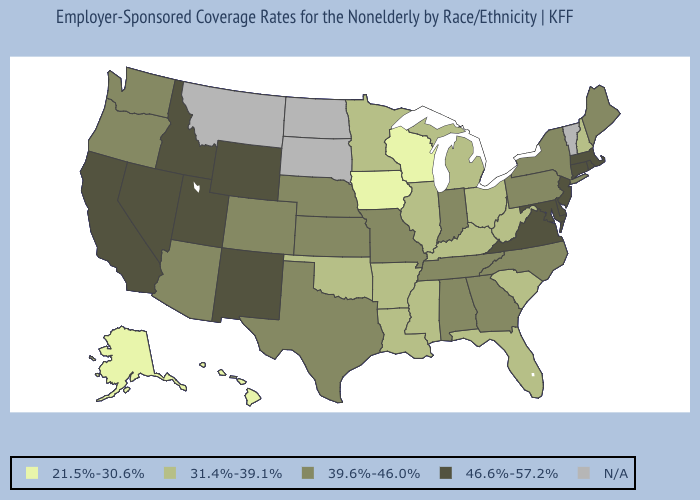Which states have the lowest value in the USA?
Quick response, please. Alaska, Hawaii, Iowa, Wisconsin. Among the states that border New Mexico , does Texas have the lowest value?
Quick response, please. No. How many symbols are there in the legend?
Short answer required. 5. What is the value of North Carolina?
Short answer required. 39.6%-46.0%. Does Iowa have the lowest value in the USA?
Give a very brief answer. Yes. What is the lowest value in states that border West Virginia?
Short answer required. 31.4%-39.1%. Is the legend a continuous bar?
Write a very short answer. No. Does Texas have the lowest value in the USA?
Short answer required. No. What is the lowest value in states that border Vermont?
Answer briefly. 31.4%-39.1%. What is the value of Connecticut?
Concise answer only. 46.6%-57.2%. What is the value of Maryland?
Be succinct. 46.6%-57.2%. Among the states that border New Mexico , does Utah have the highest value?
Quick response, please. Yes. What is the value of Delaware?
Keep it brief. 46.6%-57.2%. What is the value of New York?
Write a very short answer. 39.6%-46.0%. What is the value of New York?
Keep it brief. 39.6%-46.0%. 